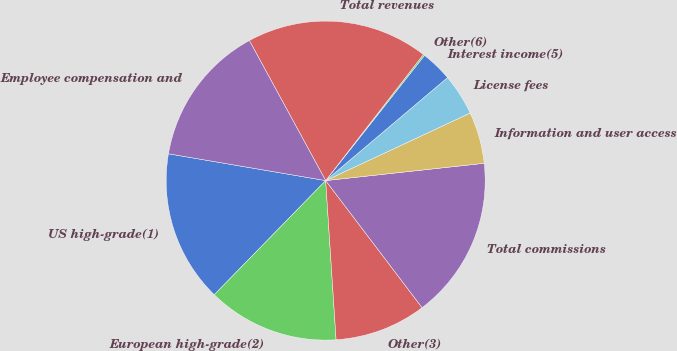<chart> <loc_0><loc_0><loc_500><loc_500><pie_chart><fcel>US high-grade(1)<fcel>European high-grade(2)<fcel>Other(3)<fcel>Total commissions<fcel>Information and user access<fcel>License fees<fcel>Interest income(5)<fcel>Other(6)<fcel>Total revenues<fcel>Employee compensation and<nl><fcel>15.38%<fcel>13.35%<fcel>9.29%<fcel>16.4%<fcel>5.23%<fcel>4.21%<fcel>3.19%<fcel>0.15%<fcel>18.43%<fcel>14.37%<nl></chart> 